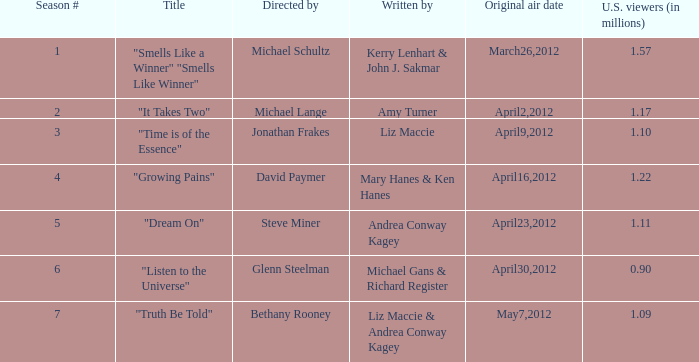What is the designation of the episode/s penned by michael gans & richard register? "Listen to the Universe". 